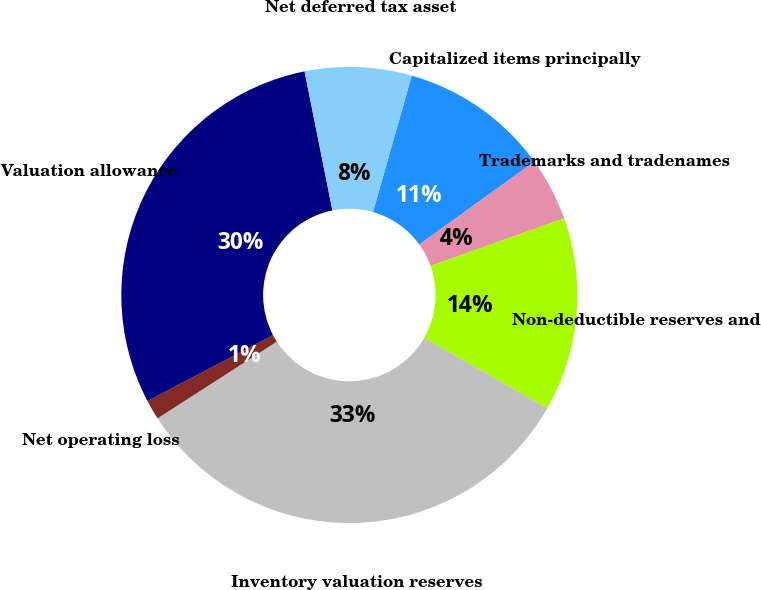Convert chart. <chart><loc_0><loc_0><loc_500><loc_500><pie_chart><fcel>Capitalized items principally<fcel>Trademarks and tradenames<fcel>Non-deductible reserves and<fcel>Inventory valuation reserves<fcel>Net operating loss<fcel>Valuation allowance<fcel>Net deferred tax asset<nl><fcel>10.65%<fcel>4.48%<fcel>13.73%<fcel>32.63%<fcel>1.4%<fcel>29.55%<fcel>7.56%<nl></chart> 